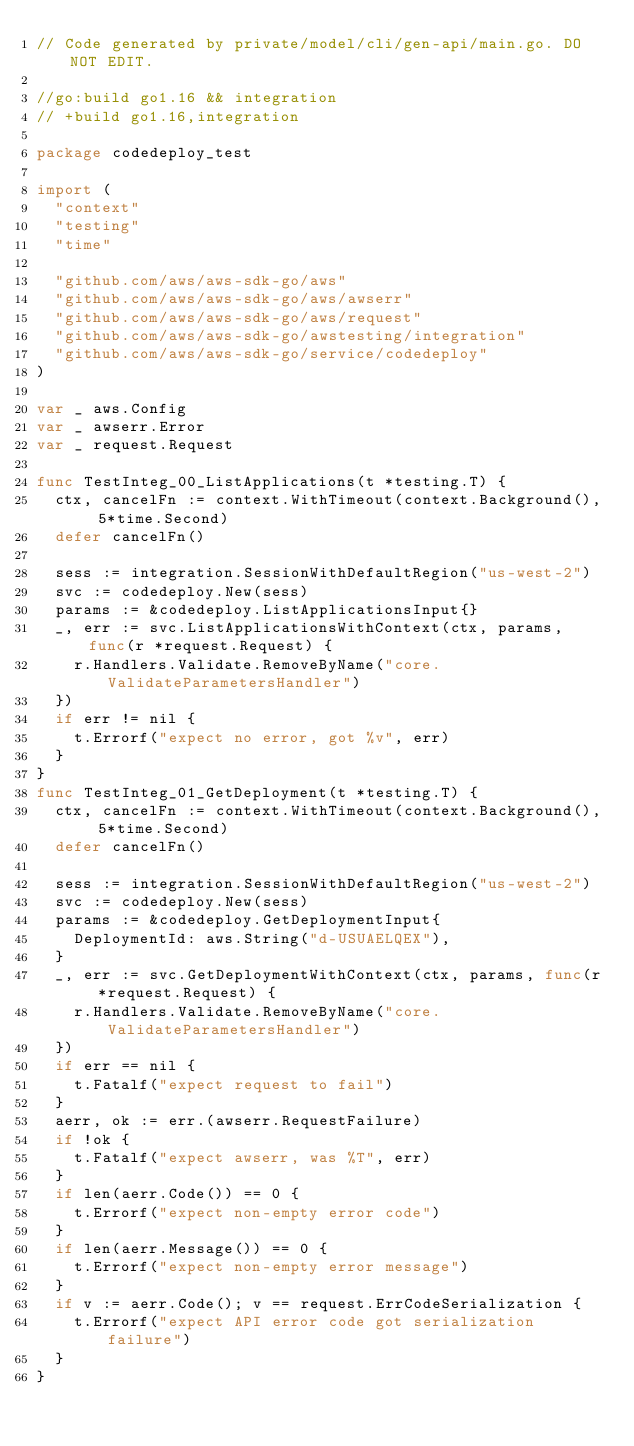<code> <loc_0><loc_0><loc_500><loc_500><_Go_>// Code generated by private/model/cli/gen-api/main.go. DO NOT EDIT.

//go:build go1.16 && integration
// +build go1.16,integration

package codedeploy_test

import (
	"context"
	"testing"
	"time"

	"github.com/aws/aws-sdk-go/aws"
	"github.com/aws/aws-sdk-go/aws/awserr"
	"github.com/aws/aws-sdk-go/aws/request"
	"github.com/aws/aws-sdk-go/awstesting/integration"
	"github.com/aws/aws-sdk-go/service/codedeploy"
)

var _ aws.Config
var _ awserr.Error
var _ request.Request

func TestInteg_00_ListApplications(t *testing.T) {
	ctx, cancelFn := context.WithTimeout(context.Background(), 5*time.Second)
	defer cancelFn()

	sess := integration.SessionWithDefaultRegion("us-west-2")
	svc := codedeploy.New(sess)
	params := &codedeploy.ListApplicationsInput{}
	_, err := svc.ListApplicationsWithContext(ctx, params, func(r *request.Request) {
		r.Handlers.Validate.RemoveByName("core.ValidateParametersHandler")
	})
	if err != nil {
		t.Errorf("expect no error, got %v", err)
	}
}
func TestInteg_01_GetDeployment(t *testing.T) {
	ctx, cancelFn := context.WithTimeout(context.Background(), 5*time.Second)
	defer cancelFn()

	sess := integration.SessionWithDefaultRegion("us-west-2")
	svc := codedeploy.New(sess)
	params := &codedeploy.GetDeploymentInput{
		DeploymentId: aws.String("d-USUAELQEX"),
	}
	_, err := svc.GetDeploymentWithContext(ctx, params, func(r *request.Request) {
		r.Handlers.Validate.RemoveByName("core.ValidateParametersHandler")
	})
	if err == nil {
		t.Fatalf("expect request to fail")
	}
	aerr, ok := err.(awserr.RequestFailure)
	if !ok {
		t.Fatalf("expect awserr, was %T", err)
	}
	if len(aerr.Code()) == 0 {
		t.Errorf("expect non-empty error code")
	}
	if len(aerr.Message()) == 0 {
		t.Errorf("expect non-empty error message")
	}
	if v := aerr.Code(); v == request.ErrCodeSerialization {
		t.Errorf("expect API error code got serialization failure")
	}
}
</code> 